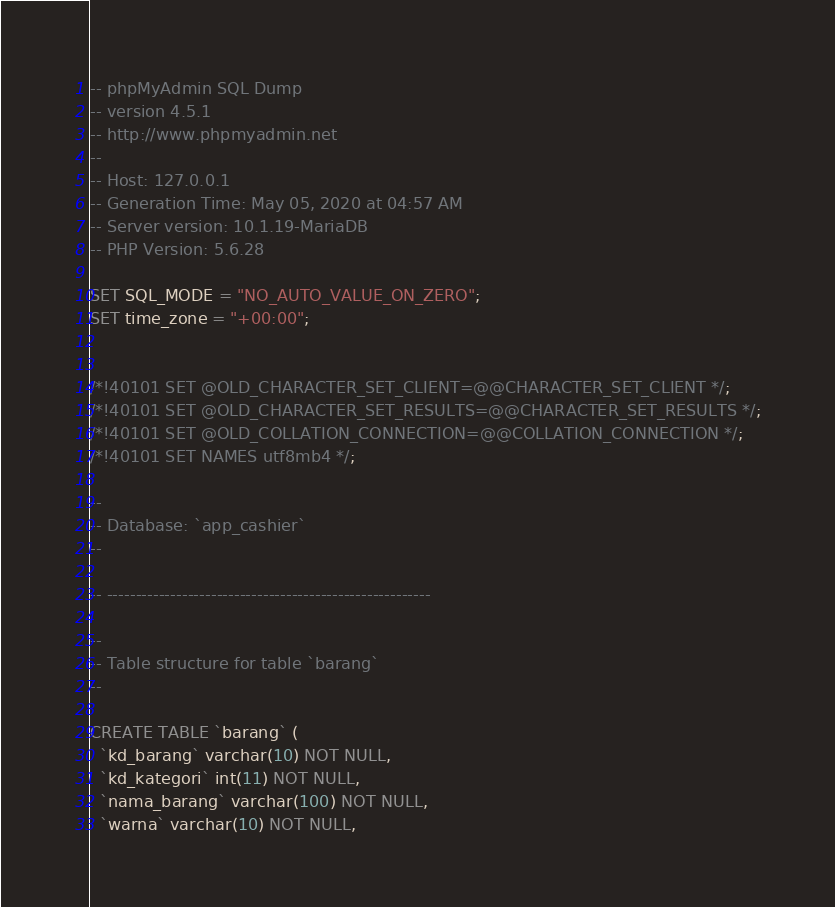Convert code to text. <code><loc_0><loc_0><loc_500><loc_500><_SQL_>-- phpMyAdmin SQL Dump
-- version 4.5.1
-- http://www.phpmyadmin.net
--
-- Host: 127.0.0.1
-- Generation Time: May 05, 2020 at 04:57 AM
-- Server version: 10.1.19-MariaDB
-- PHP Version: 5.6.28

SET SQL_MODE = "NO_AUTO_VALUE_ON_ZERO";
SET time_zone = "+00:00";


/*!40101 SET @OLD_CHARACTER_SET_CLIENT=@@CHARACTER_SET_CLIENT */;
/*!40101 SET @OLD_CHARACTER_SET_RESULTS=@@CHARACTER_SET_RESULTS */;
/*!40101 SET @OLD_COLLATION_CONNECTION=@@COLLATION_CONNECTION */;
/*!40101 SET NAMES utf8mb4 */;

--
-- Database: `app_cashier`
--

-- --------------------------------------------------------

--
-- Table structure for table `barang`
--

CREATE TABLE `barang` (
  `kd_barang` varchar(10) NOT NULL,
  `kd_kategori` int(11) NOT NULL,
  `nama_barang` varchar(100) NOT NULL,
  `warna` varchar(10) NOT NULL,</code> 